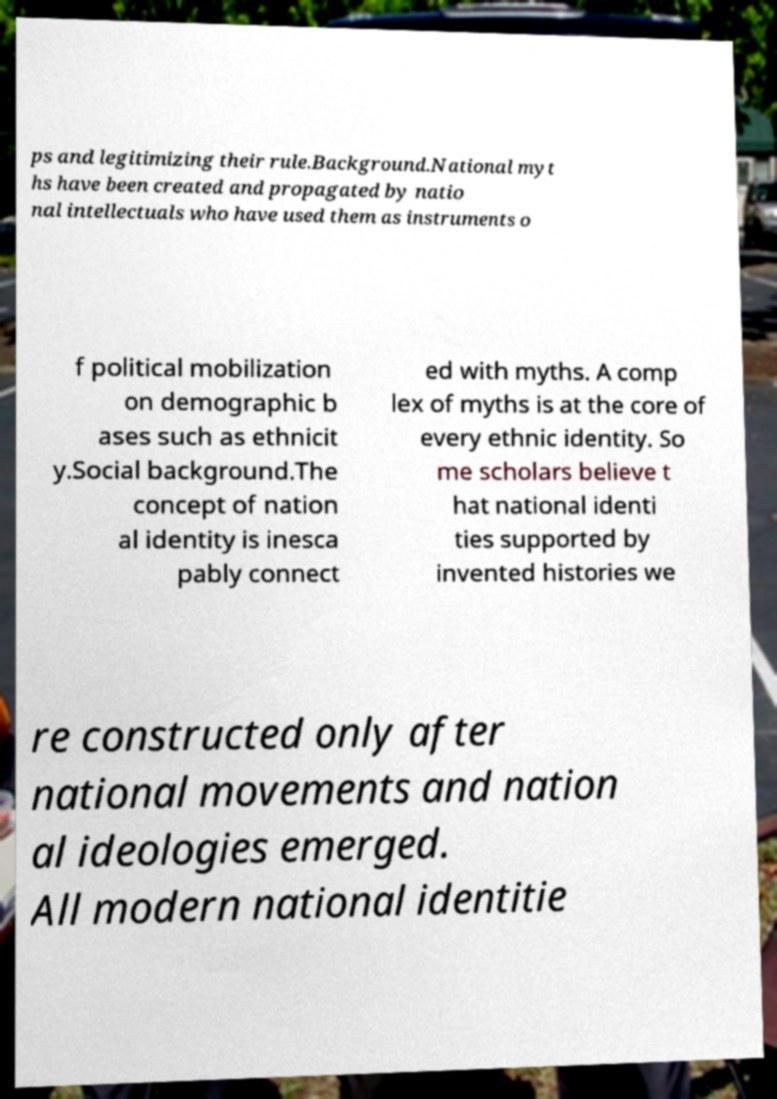Can you accurately transcribe the text from the provided image for me? ps and legitimizing their rule.Background.National myt hs have been created and propagated by natio nal intellectuals who have used them as instruments o f political mobilization on demographic b ases such as ethnicit y.Social background.The concept of nation al identity is inesca pably connect ed with myths. A comp lex of myths is at the core of every ethnic identity. So me scholars believe t hat national identi ties supported by invented histories we re constructed only after national movements and nation al ideologies emerged. All modern national identitie 